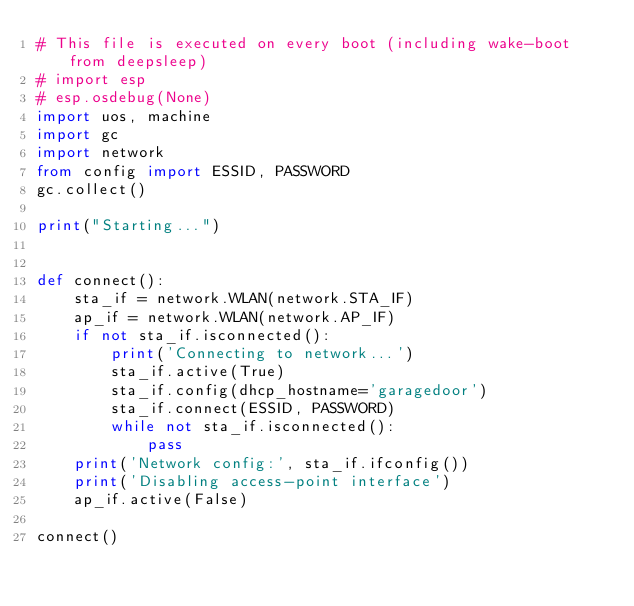<code> <loc_0><loc_0><loc_500><loc_500><_Python_># This file is executed on every boot (including wake-boot from deepsleep)
# import esp
# esp.osdebug(None)
import uos, machine
import gc
import network
from config import ESSID, PASSWORD
gc.collect()

print("Starting...")


def connect():
    sta_if = network.WLAN(network.STA_IF)
    ap_if = network.WLAN(network.AP_IF)
    if not sta_if.isconnected():
        print('Connecting to network...')
        sta_if.active(True)
        sta_if.config(dhcp_hostname='garagedoor')
        sta_if.connect(ESSID, PASSWORD)
        while not sta_if.isconnected():
            pass
    print('Network config:', sta_if.ifconfig())
    print('Disabling access-point interface')
    ap_if.active(False)

connect()
</code> 